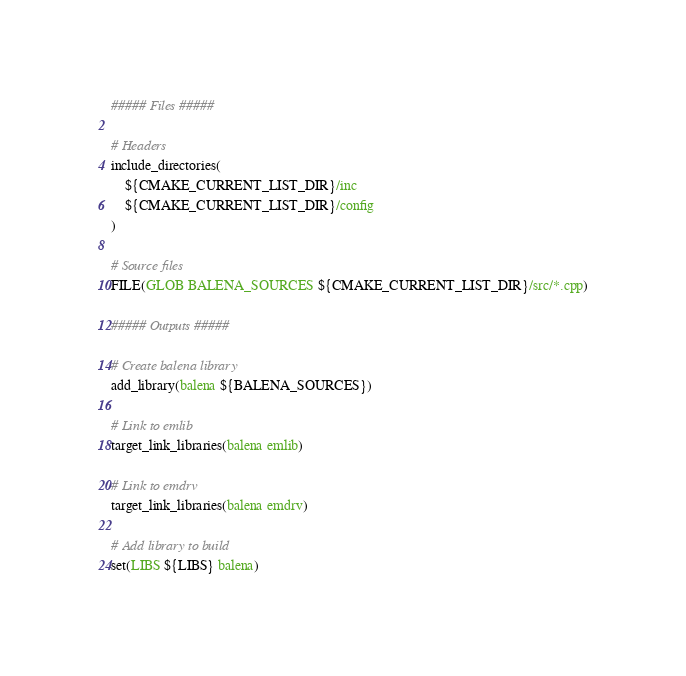<code> <loc_0><loc_0><loc_500><loc_500><_CMake_>##### Files #####

# Headers
include_directories(
    ${CMAKE_CURRENT_LIST_DIR}/inc
    ${CMAKE_CURRENT_LIST_DIR}/config
)

# Source files
FILE(GLOB BALENA_SOURCES ${CMAKE_CURRENT_LIST_DIR}/src/*.cpp)

##### Outputs #####

# Create balena library
add_library(balena ${BALENA_SOURCES})

# Link to emlib
target_link_libraries(balena emlib)

# Link to emdrv
target_link_libraries(balena emdrv)

# Add library to build
set(LIBS ${LIBS} balena)</code> 